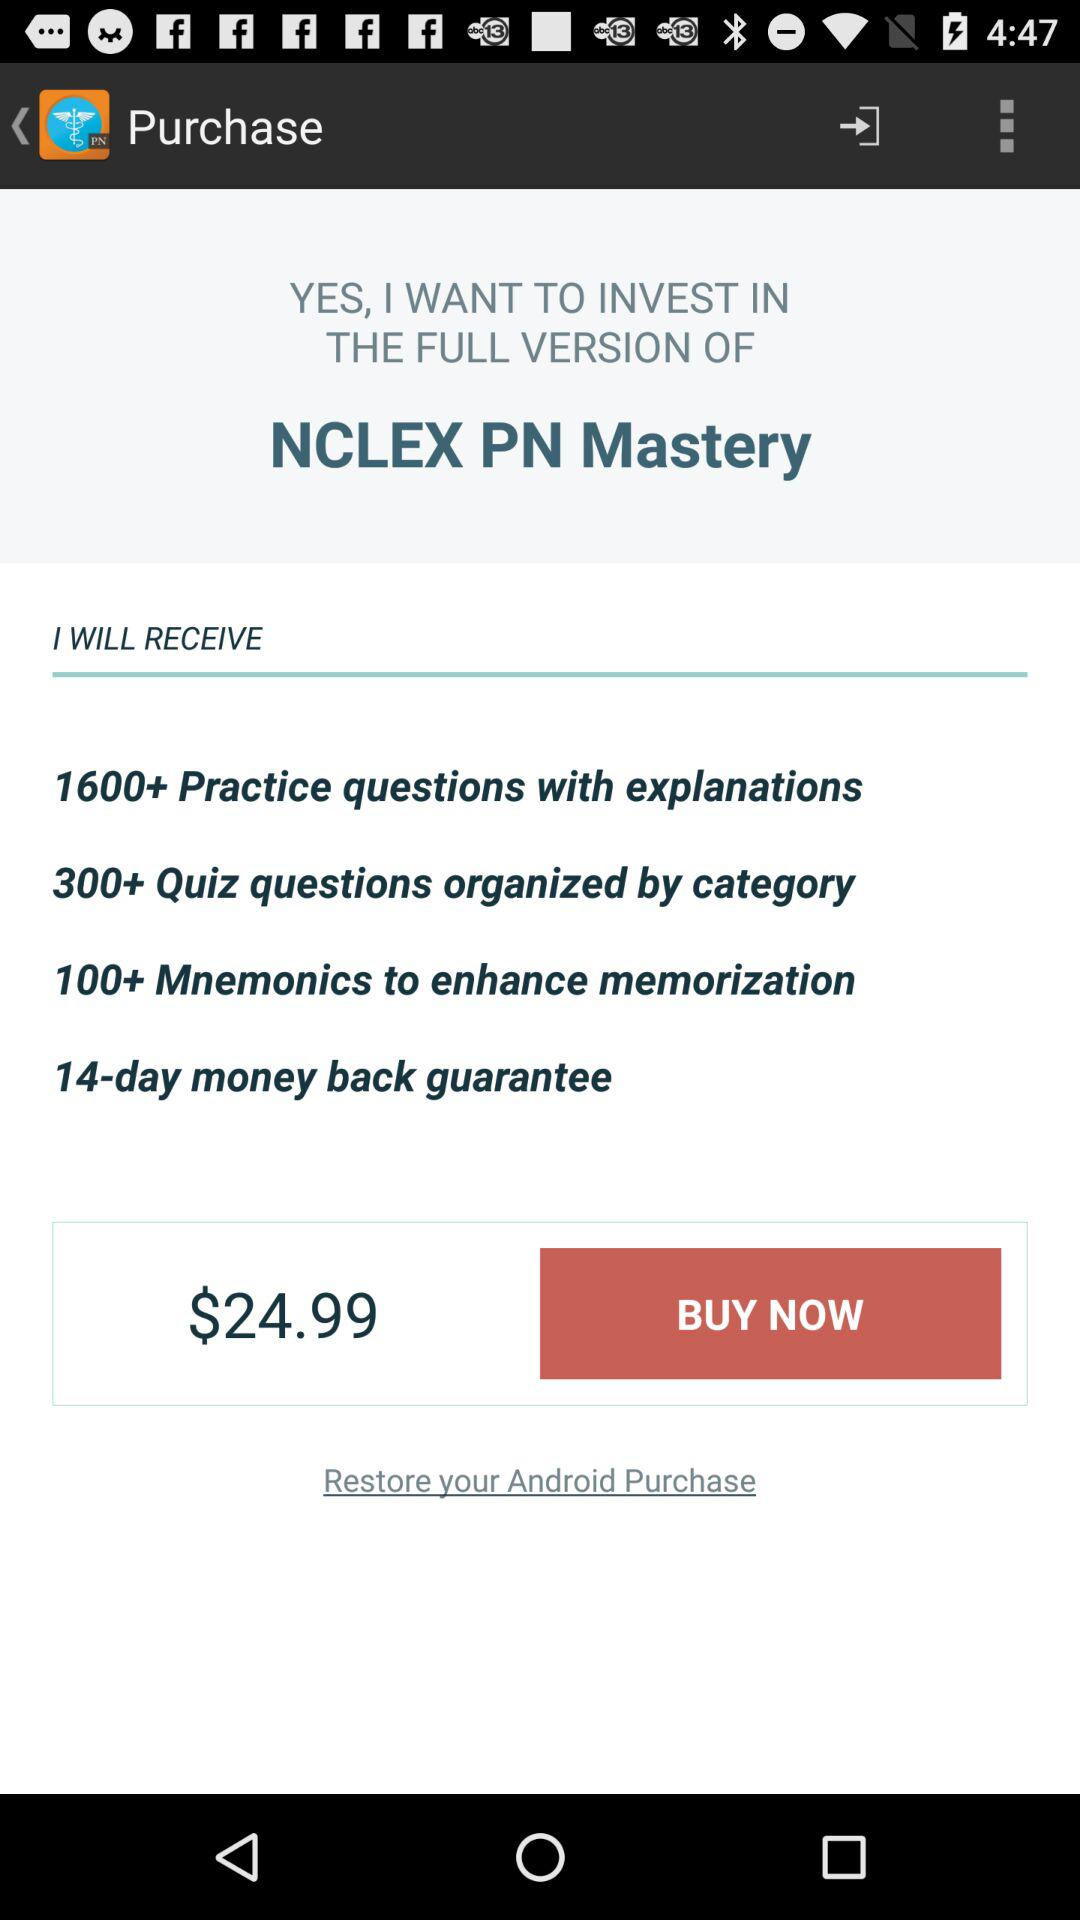What is the count of mnemonics? There are more than 100 mnemonics. 